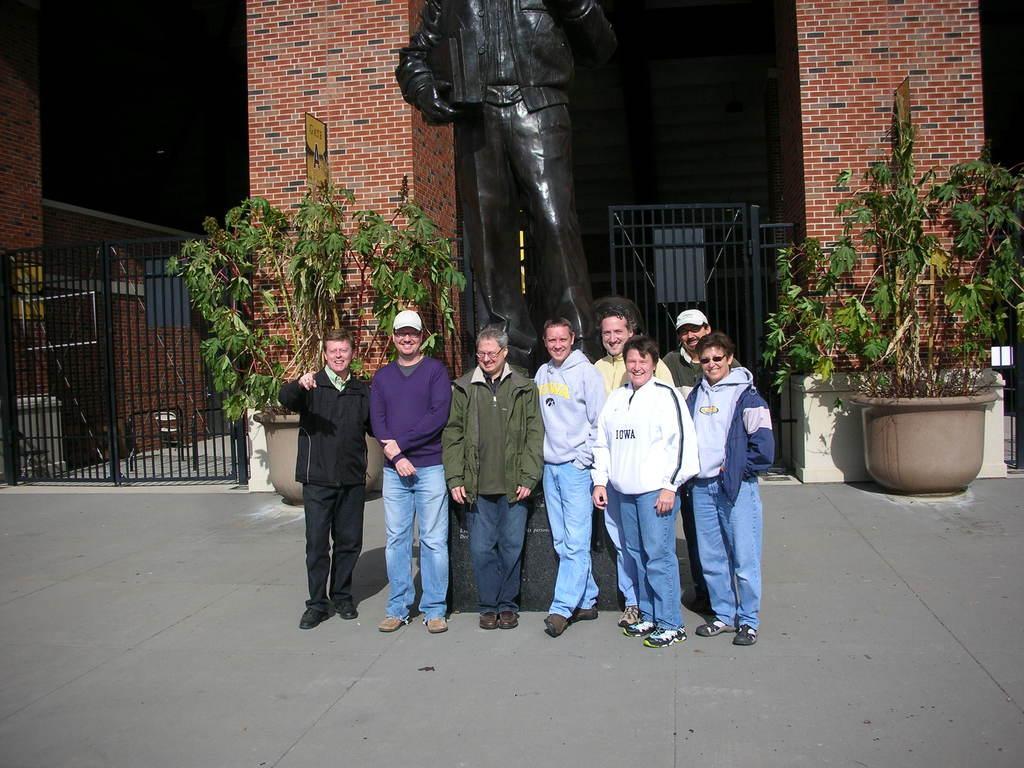In one or two sentences, can you explain what this image depicts? In this image I can see in the middle a group of persons are standing, in the background there are trees and at the top there is a statue and a building. 